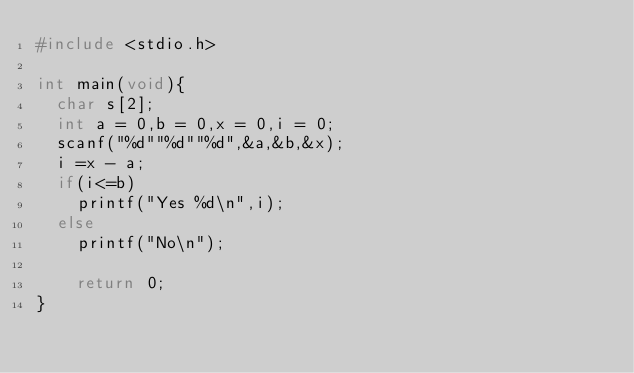Convert code to text. <code><loc_0><loc_0><loc_500><loc_500><_C_>#include <stdio.h>

int main(void){
	char s[2];
	int a = 0,b = 0,x = 0,i = 0;
	scanf("%d""%d""%d",&a,&b,&x);
	i =x - a;
	if(i<=b)
		printf("Yes %d\n",i);
	else
		printf("No\n");
	
		return 0;
}</code> 